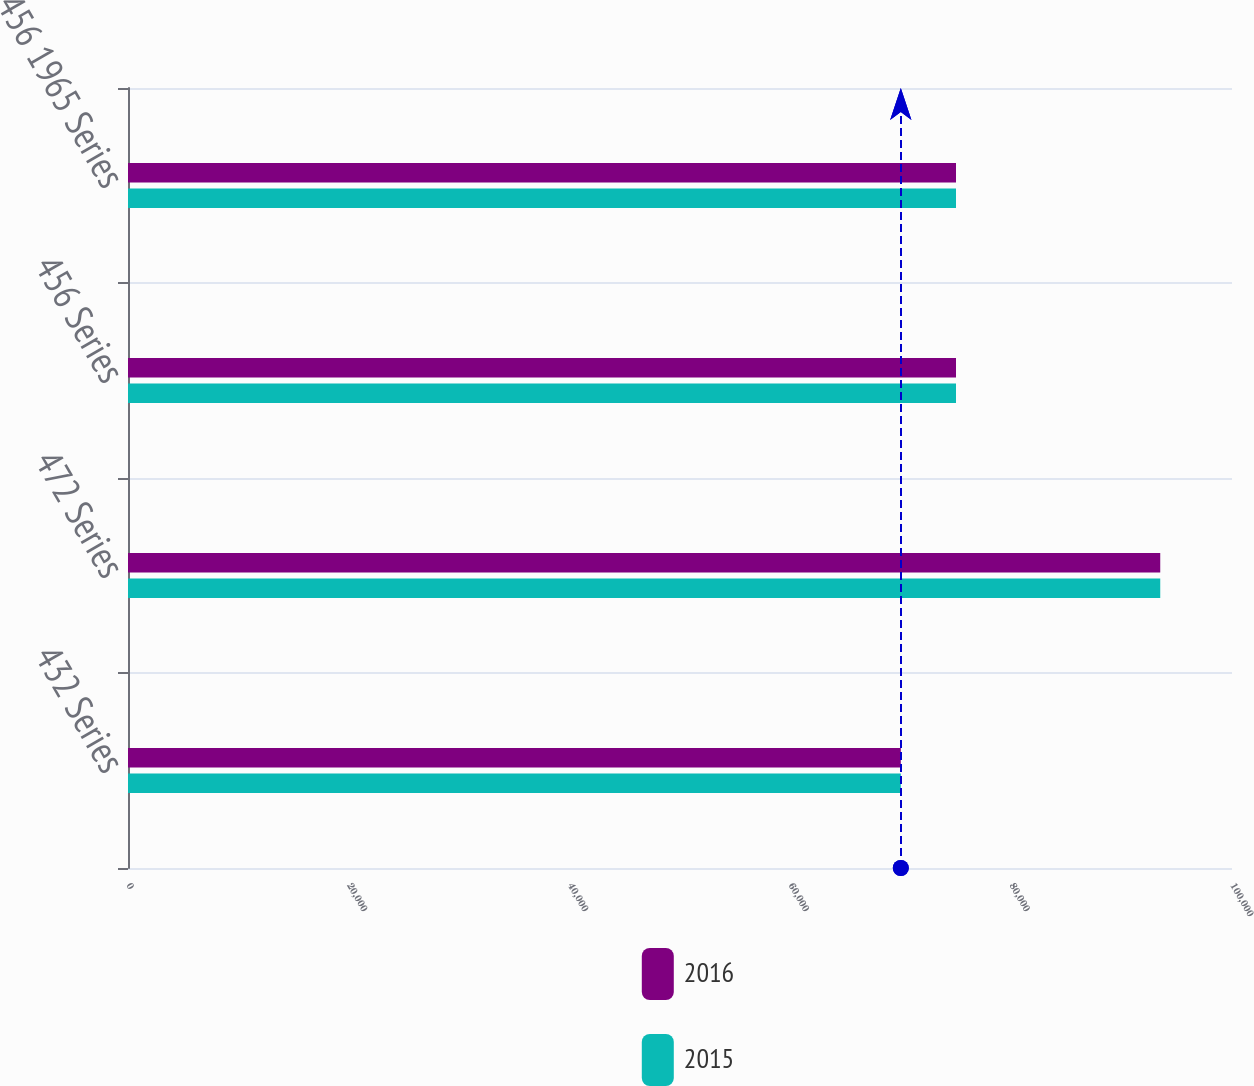Convert chart. <chart><loc_0><loc_0><loc_500><loc_500><stacked_bar_chart><ecel><fcel>432 Series<fcel>472 Series<fcel>456 Series<fcel>456 1965 Series<nl><fcel>2016<fcel>70000<fcel>93500<fcel>75000<fcel>75000<nl><fcel>2015<fcel>70000<fcel>93500<fcel>75000<fcel>75000<nl></chart> 